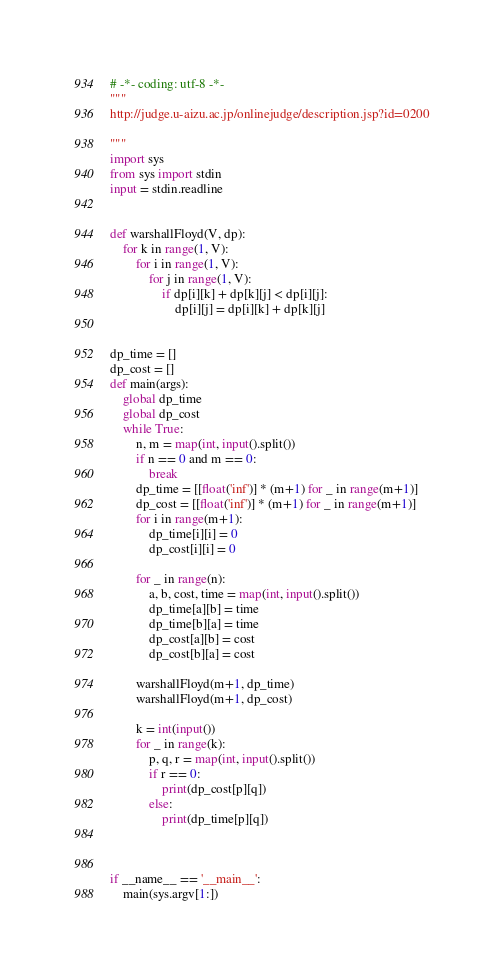Convert code to text. <code><loc_0><loc_0><loc_500><loc_500><_Python_># -*- coding: utf-8 -*-
"""
http://judge.u-aizu.ac.jp/onlinejudge/description.jsp?id=0200

"""
import sys
from sys import stdin
input = stdin.readline


def warshallFloyd(V, dp):
    for k in range(1, V):
        for i in range(1, V):
            for j in range(1, V):
                if dp[i][k] + dp[k][j] < dp[i][j]:
                    dp[i][j] = dp[i][k] + dp[k][j]


dp_time = []
dp_cost = []
def main(args):
    global dp_time
    global dp_cost
    while True:
        n, m = map(int, input().split())
        if n == 0 and m == 0:
            break
        dp_time = [[float('inf')] * (m+1) for _ in range(m+1)]
        dp_cost = [[float('inf')] * (m+1) for _ in range(m+1)]
        for i in range(m+1):
            dp_time[i][i] = 0
            dp_cost[i][i] = 0

        for _ in range(n):
            a, b, cost, time = map(int, input().split())
            dp_time[a][b] = time
            dp_time[b][a] = time
            dp_cost[a][b] = cost
            dp_cost[b][a] = cost

        warshallFloyd(m+1, dp_time)
        warshallFloyd(m+1, dp_cost)

        k = int(input())
        for _ in range(k):
            p, q, r = map(int, input().split())
            if r == 0:
                print(dp_cost[p][q])
            else:
                print(dp_time[p][q])



if __name__ == '__main__':
    main(sys.argv[1:])</code> 